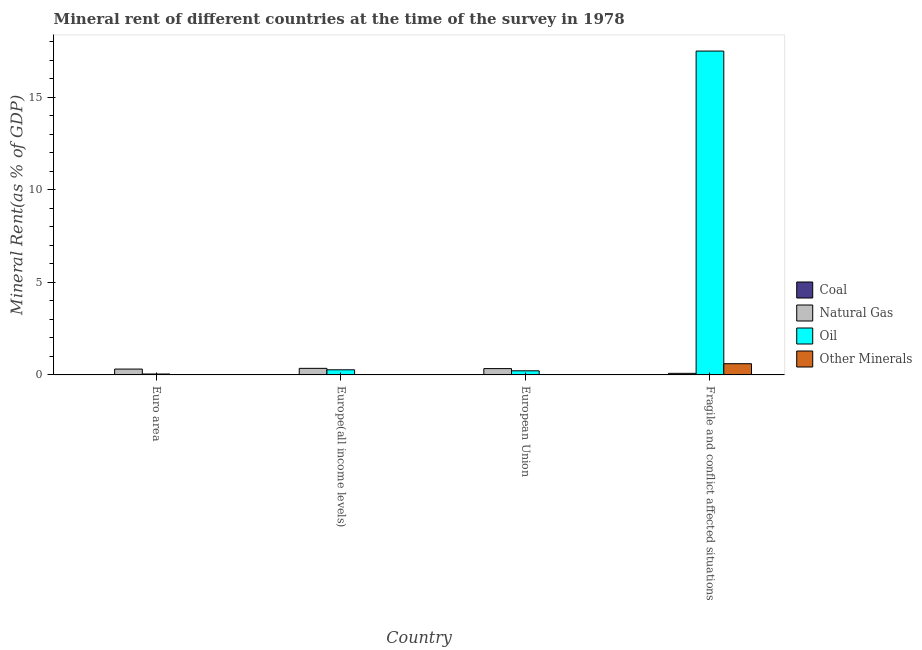Are the number of bars on each tick of the X-axis equal?
Provide a short and direct response. Yes. How many bars are there on the 3rd tick from the left?
Offer a very short reply. 4. What is the natural gas rent in Europe(all income levels)?
Give a very brief answer. 0.35. Across all countries, what is the maximum natural gas rent?
Provide a short and direct response. 0.35. Across all countries, what is the minimum oil rent?
Your response must be concise. 0.05. In which country was the coal rent maximum?
Provide a succinct answer. Fragile and conflict affected situations. What is the total  rent of other minerals in the graph?
Provide a short and direct response. 0.64. What is the difference between the oil rent in Europe(all income levels) and that in Fragile and conflict affected situations?
Offer a terse response. -17.23. What is the difference between the  rent of other minerals in Euro area and the natural gas rent in European Union?
Provide a succinct answer. -0.33. What is the average  rent of other minerals per country?
Give a very brief answer. 0.16. What is the difference between the oil rent and natural gas rent in European Union?
Ensure brevity in your answer.  -0.12. In how many countries, is the coal rent greater than 4 %?
Provide a short and direct response. 0. What is the ratio of the coal rent in Europe(all income levels) to that in Fragile and conflict affected situations?
Keep it short and to the point. 0.2. What is the difference between the highest and the second highest natural gas rent?
Provide a succinct answer. 0.01. What is the difference between the highest and the lowest natural gas rent?
Make the answer very short. 0.27. In how many countries, is the coal rent greater than the average coal rent taken over all countries?
Make the answer very short. 1. Is the sum of the natural gas rent in European Union and Fragile and conflict affected situations greater than the maximum oil rent across all countries?
Make the answer very short. No. Is it the case that in every country, the sum of the coal rent and oil rent is greater than the sum of  rent of other minerals and natural gas rent?
Make the answer very short. No. What does the 4th bar from the left in European Union represents?
Keep it short and to the point. Other Minerals. What does the 2nd bar from the right in European Union represents?
Your answer should be compact. Oil. Is it the case that in every country, the sum of the coal rent and natural gas rent is greater than the oil rent?
Provide a short and direct response. No. How many bars are there?
Your answer should be compact. 16. Are all the bars in the graph horizontal?
Your answer should be compact. No. How many countries are there in the graph?
Your answer should be very brief. 4. Are the values on the major ticks of Y-axis written in scientific E-notation?
Offer a very short reply. No. Does the graph contain grids?
Provide a succinct answer. No. What is the title of the graph?
Keep it short and to the point. Mineral rent of different countries at the time of the survey in 1978. What is the label or title of the X-axis?
Ensure brevity in your answer.  Country. What is the label or title of the Y-axis?
Ensure brevity in your answer.  Mineral Rent(as % of GDP). What is the Mineral Rent(as % of GDP) of Coal in Euro area?
Your answer should be compact. 0. What is the Mineral Rent(as % of GDP) in Natural Gas in Euro area?
Make the answer very short. 0.32. What is the Mineral Rent(as % of GDP) in Oil in Euro area?
Offer a very short reply. 0.05. What is the Mineral Rent(as % of GDP) of Other Minerals in Euro area?
Offer a very short reply. 0.01. What is the Mineral Rent(as % of GDP) of Coal in Europe(all income levels)?
Provide a succinct answer. 0. What is the Mineral Rent(as % of GDP) in Natural Gas in Europe(all income levels)?
Provide a succinct answer. 0.35. What is the Mineral Rent(as % of GDP) in Oil in Europe(all income levels)?
Your answer should be very brief. 0.28. What is the Mineral Rent(as % of GDP) of Other Minerals in Europe(all income levels)?
Offer a terse response. 0.01. What is the Mineral Rent(as % of GDP) in Coal in European Union?
Offer a very short reply. 0. What is the Mineral Rent(as % of GDP) of Natural Gas in European Union?
Offer a terse response. 0.34. What is the Mineral Rent(as % of GDP) in Oil in European Union?
Provide a short and direct response. 0.22. What is the Mineral Rent(as % of GDP) in Other Minerals in European Union?
Your answer should be compact. 0.01. What is the Mineral Rent(as % of GDP) in Coal in Fragile and conflict affected situations?
Offer a very short reply. 0.02. What is the Mineral Rent(as % of GDP) of Natural Gas in Fragile and conflict affected situations?
Your answer should be compact. 0.08. What is the Mineral Rent(as % of GDP) in Oil in Fragile and conflict affected situations?
Provide a succinct answer. 17.5. What is the Mineral Rent(as % of GDP) in Other Minerals in Fragile and conflict affected situations?
Offer a terse response. 0.61. Across all countries, what is the maximum Mineral Rent(as % of GDP) of Coal?
Provide a short and direct response. 0.02. Across all countries, what is the maximum Mineral Rent(as % of GDP) of Natural Gas?
Give a very brief answer. 0.35. Across all countries, what is the maximum Mineral Rent(as % of GDP) in Oil?
Provide a succinct answer. 17.5. Across all countries, what is the maximum Mineral Rent(as % of GDP) of Other Minerals?
Ensure brevity in your answer.  0.61. Across all countries, what is the minimum Mineral Rent(as % of GDP) of Coal?
Your answer should be compact. 0. Across all countries, what is the minimum Mineral Rent(as % of GDP) of Natural Gas?
Your answer should be very brief. 0.08. Across all countries, what is the minimum Mineral Rent(as % of GDP) in Oil?
Offer a very short reply. 0.05. Across all countries, what is the minimum Mineral Rent(as % of GDP) of Other Minerals?
Ensure brevity in your answer.  0.01. What is the total Mineral Rent(as % of GDP) of Coal in the graph?
Give a very brief answer. 0.03. What is the total Mineral Rent(as % of GDP) in Natural Gas in the graph?
Ensure brevity in your answer.  1.1. What is the total Mineral Rent(as % of GDP) of Oil in the graph?
Your response must be concise. 18.05. What is the total Mineral Rent(as % of GDP) of Other Minerals in the graph?
Your response must be concise. 0.64. What is the difference between the Mineral Rent(as % of GDP) of Coal in Euro area and that in Europe(all income levels)?
Your answer should be compact. -0. What is the difference between the Mineral Rent(as % of GDP) of Natural Gas in Euro area and that in Europe(all income levels)?
Offer a very short reply. -0.04. What is the difference between the Mineral Rent(as % of GDP) of Oil in Euro area and that in Europe(all income levels)?
Provide a succinct answer. -0.23. What is the difference between the Mineral Rent(as % of GDP) in Other Minerals in Euro area and that in Europe(all income levels)?
Your answer should be compact. -0. What is the difference between the Mineral Rent(as % of GDP) in Coal in Euro area and that in European Union?
Make the answer very short. -0. What is the difference between the Mineral Rent(as % of GDP) of Natural Gas in Euro area and that in European Union?
Provide a succinct answer. -0.03. What is the difference between the Mineral Rent(as % of GDP) in Oil in Euro area and that in European Union?
Give a very brief answer. -0.17. What is the difference between the Mineral Rent(as % of GDP) of Other Minerals in Euro area and that in European Union?
Your response must be concise. -0. What is the difference between the Mineral Rent(as % of GDP) of Coal in Euro area and that in Fragile and conflict affected situations?
Ensure brevity in your answer.  -0.02. What is the difference between the Mineral Rent(as % of GDP) in Natural Gas in Euro area and that in Fragile and conflict affected situations?
Your answer should be compact. 0.23. What is the difference between the Mineral Rent(as % of GDP) of Oil in Euro area and that in Fragile and conflict affected situations?
Your answer should be compact. -17.46. What is the difference between the Mineral Rent(as % of GDP) in Other Minerals in Euro area and that in Fragile and conflict affected situations?
Provide a short and direct response. -0.6. What is the difference between the Mineral Rent(as % of GDP) of Coal in Europe(all income levels) and that in European Union?
Offer a very short reply. -0. What is the difference between the Mineral Rent(as % of GDP) of Natural Gas in Europe(all income levels) and that in European Union?
Provide a succinct answer. 0.01. What is the difference between the Mineral Rent(as % of GDP) in Oil in Europe(all income levels) and that in European Union?
Offer a very short reply. 0.05. What is the difference between the Mineral Rent(as % of GDP) of Other Minerals in Europe(all income levels) and that in European Union?
Provide a succinct answer. 0. What is the difference between the Mineral Rent(as % of GDP) in Coal in Europe(all income levels) and that in Fragile and conflict affected situations?
Make the answer very short. -0.02. What is the difference between the Mineral Rent(as % of GDP) in Natural Gas in Europe(all income levels) and that in Fragile and conflict affected situations?
Ensure brevity in your answer.  0.27. What is the difference between the Mineral Rent(as % of GDP) in Oil in Europe(all income levels) and that in Fragile and conflict affected situations?
Give a very brief answer. -17.23. What is the difference between the Mineral Rent(as % of GDP) in Other Minerals in Europe(all income levels) and that in Fragile and conflict affected situations?
Make the answer very short. -0.59. What is the difference between the Mineral Rent(as % of GDP) in Coal in European Union and that in Fragile and conflict affected situations?
Your answer should be very brief. -0.02. What is the difference between the Mineral Rent(as % of GDP) in Natural Gas in European Union and that in Fragile and conflict affected situations?
Offer a very short reply. 0.26. What is the difference between the Mineral Rent(as % of GDP) of Oil in European Union and that in Fragile and conflict affected situations?
Ensure brevity in your answer.  -17.28. What is the difference between the Mineral Rent(as % of GDP) of Other Minerals in European Union and that in Fragile and conflict affected situations?
Make the answer very short. -0.6. What is the difference between the Mineral Rent(as % of GDP) of Coal in Euro area and the Mineral Rent(as % of GDP) of Natural Gas in Europe(all income levels)?
Offer a terse response. -0.35. What is the difference between the Mineral Rent(as % of GDP) in Coal in Euro area and the Mineral Rent(as % of GDP) in Oil in Europe(all income levels)?
Your response must be concise. -0.27. What is the difference between the Mineral Rent(as % of GDP) in Coal in Euro area and the Mineral Rent(as % of GDP) in Other Minerals in Europe(all income levels)?
Offer a terse response. -0.01. What is the difference between the Mineral Rent(as % of GDP) in Natural Gas in Euro area and the Mineral Rent(as % of GDP) in Oil in Europe(all income levels)?
Keep it short and to the point. 0.04. What is the difference between the Mineral Rent(as % of GDP) in Natural Gas in Euro area and the Mineral Rent(as % of GDP) in Other Minerals in Europe(all income levels)?
Make the answer very short. 0.3. What is the difference between the Mineral Rent(as % of GDP) in Oil in Euro area and the Mineral Rent(as % of GDP) in Other Minerals in Europe(all income levels)?
Provide a succinct answer. 0.04. What is the difference between the Mineral Rent(as % of GDP) in Coal in Euro area and the Mineral Rent(as % of GDP) in Natural Gas in European Union?
Provide a short and direct response. -0.34. What is the difference between the Mineral Rent(as % of GDP) of Coal in Euro area and the Mineral Rent(as % of GDP) of Oil in European Union?
Give a very brief answer. -0.22. What is the difference between the Mineral Rent(as % of GDP) of Coal in Euro area and the Mineral Rent(as % of GDP) of Other Minerals in European Union?
Your answer should be compact. -0.01. What is the difference between the Mineral Rent(as % of GDP) in Natural Gas in Euro area and the Mineral Rent(as % of GDP) in Oil in European Union?
Your answer should be compact. 0.09. What is the difference between the Mineral Rent(as % of GDP) of Natural Gas in Euro area and the Mineral Rent(as % of GDP) of Other Minerals in European Union?
Keep it short and to the point. 0.31. What is the difference between the Mineral Rent(as % of GDP) of Oil in Euro area and the Mineral Rent(as % of GDP) of Other Minerals in European Union?
Your answer should be compact. 0.04. What is the difference between the Mineral Rent(as % of GDP) of Coal in Euro area and the Mineral Rent(as % of GDP) of Natural Gas in Fragile and conflict affected situations?
Provide a short and direct response. -0.08. What is the difference between the Mineral Rent(as % of GDP) in Coal in Euro area and the Mineral Rent(as % of GDP) in Oil in Fragile and conflict affected situations?
Provide a succinct answer. -17.5. What is the difference between the Mineral Rent(as % of GDP) in Coal in Euro area and the Mineral Rent(as % of GDP) in Other Minerals in Fragile and conflict affected situations?
Your response must be concise. -0.6. What is the difference between the Mineral Rent(as % of GDP) in Natural Gas in Euro area and the Mineral Rent(as % of GDP) in Oil in Fragile and conflict affected situations?
Provide a succinct answer. -17.19. What is the difference between the Mineral Rent(as % of GDP) of Natural Gas in Euro area and the Mineral Rent(as % of GDP) of Other Minerals in Fragile and conflict affected situations?
Provide a short and direct response. -0.29. What is the difference between the Mineral Rent(as % of GDP) of Oil in Euro area and the Mineral Rent(as % of GDP) of Other Minerals in Fragile and conflict affected situations?
Make the answer very short. -0.56. What is the difference between the Mineral Rent(as % of GDP) in Coal in Europe(all income levels) and the Mineral Rent(as % of GDP) in Natural Gas in European Union?
Keep it short and to the point. -0.34. What is the difference between the Mineral Rent(as % of GDP) of Coal in Europe(all income levels) and the Mineral Rent(as % of GDP) of Oil in European Union?
Provide a short and direct response. -0.22. What is the difference between the Mineral Rent(as % of GDP) in Coal in Europe(all income levels) and the Mineral Rent(as % of GDP) in Other Minerals in European Union?
Make the answer very short. -0.01. What is the difference between the Mineral Rent(as % of GDP) in Natural Gas in Europe(all income levels) and the Mineral Rent(as % of GDP) in Oil in European Union?
Make the answer very short. 0.13. What is the difference between the Mineral Rent(as % of GDP) of Natural Gas in Europe(all income levels) and the Mineral Rent(as % of GDP) of Other Minerals in European Union?
Your response must be concise. 0.35. What is the difference between the Mineral Rent(as % of GDP) in Oil in Europe(all income levels) and the Mineral Rent(as % of GDP) in Other Minerals in European Union?
Give a very brief answer. 0.27. What is the difference between the Mineral Rent(as % of GDP) in Coal in Europe(all income levels) and the Mineral Rent(as % of GDP) in Natural Gas in Fragile and conflict affected situations?
Keep it short and to the point. -0.08. What is the difference between the Mineral Rent(as % of GDP) in Coal in Europe(all income levels) and the Mineral Rent(as % of GDP) in Oil in Fragile and conflict affected situations?
Your answer should be very brief. -17.5. What is the difference between the Mineral Rent(as % of GDP) of Coal in Europe(all income levels) and the Mineral Rent(as % of GDP) of Other Minerals in Fragile and conflict affected situations?
Ensure brevity in your answer.  -0.6. What is the difference between the Mineral Rent(as % of GDP) of Natural Gas in Europe(all income levels) and the Mineral Rent(as % of GDP) of Oil in Fragile and conflict affected situations?
Provide a succinct answer. -17.15. What is the difference between the Mineral Rent(as % of GDP) of Natural Gas in Europe(all income levels) and the Mineral Rent(as % of GDP) of Other Minerals in Fragile and conflict affected situations?
Provide a short and direct response. -0.25. What is the difference between the Mineral Rent(as % of GDP) of Oil in Europe(all income levels) and the Mineral Rent(as % of GDP) of Other Minerals in Fragile and conflict affected situations?
Make the answer very short. -0.33. What is the difference between the Mineral Rent(as % of GDP) of Coal in European Union and the Mineral Rent(as % of GDP) of Natural Gas in Fragile and conflict affected situations?
Make the answer very short. -0.08. What is the difference between the Mineral Rent(as % of GDP) in Coal in European Union and the Mineral Rent(as % of GDP) in Oil in Fragile and conflict affected situations?
Offer a terse response. -17.5. What is the difference between the Mineral Rent(as % of GDP) in Coal in European Union and the Mineral Rent(as % of GDP) in Other Minerals in Fragile and conflict affected situations?
Make the answer very short. -0.6. What is the difference between the Mineral Rent(as % of GDP) of Natural Gas in European Union and the Mineral Rent(as % of GDP) of Oil in Fragile and conflict affected situations?
Offer a terse response. -17.16. What is the difference between the Mineral Rent(as % of GDP) in Natural Gas in European Union and the Mineral Rent(as % of GDP) in Other Minerals in Fragile and conflict affected situations?
Provide a succinct answer. -0.26. What is the difference between the Mineral Rent(as % of GDP) in Oil in European Union and the Mineral Rent(as % of GDP) in Other Minerals in Fragile and conflict affected situations?
Give a very brief answer. -0.38. What is the average Mineral Rent(as % of GDP) of Coal per country?
Offer a terse response. 0.01. What is the average Mineral Rent(as % of GDP) in Natural Gas per country?
Provide a short and direct response. 0.27. What is the average Mineral Rent(as % of GDP) in Oil per country?
Keep it short and to the point. 4.51. What is the average Mineral Rent(as % of GDP) of Other Minerals per country?
Keep it short and to the point. 0.16. What is the difference between the Mineral Rent(as % of GDP) of Coal and Mineral Rent(as % of GDP) of Natural Gas in Euro area?
Keep it short and to the point. -0.31. What is the difference between the Mineral Rent(as % of GDP) of Coal and Mineral Rent(as % of GDP) of Oil in Euro area?
Give a very brief answer. -0.05. What is the difference between the Mineral Rent(as % of GDP) in Coal and Mineral Rent(as % of GDP) in Other Minerals in Euro area?
Provide a short and direct response. -0.01. What is the difference between the Mineral Rent(as % of GDP) of Natural Gas and Mineral Rent(as % of GDP) of Oil in Euro area?
Offer a very short reply. 0.27. What is the difference between the Mineral Rent(as % of GDP) in Natural Gas and Mineral Rent(as % of GDP) in Other Minerals in Euro area?
Your answer should be very brief. 0.31. What is the difference between the Mineral Rent(as % of GDP) of Oil and Mineral Rent(as % of GDP) of Other Minerals in Euro area?
Keep it short and to the point. 0.04. What is the difference between the Mineral Rent(as % of GDP) of Coal and Mineral Rent(as % of GDP) of Natural Gas in Europe(all income levels)?
Your answer should be very brief. -0.35. What is the difference between the Mineral Rent(as % of GDP) of Coal and Mineral Rent(as % of GDP) of Oil in Europe(all income levels)?
Your answer should be very brief. -0.27. What is the difference between the Mineral Rent(as % of GDP) in Coal and Mineral Rent(as % of GDP) in Other Minerals in Europe(all income levels)?
Your answer should be very brief. -0.01. What is the difference between the Mineral Rent(as % of GDP) in Natural Gas and Mineral Rent(as % of GDP) in Oil in Europe(all income levels)?
Make the answer very short. 0.08. What is the difference between the Mineral Rent(as % of GDP) of Natural Gas and Mineral Rent(as % of GDP) of Other Minerals in Europe(all income levels)?
Offer a terse response. 0.34. What is the difference between the Mineral Rent(as % of GDP) of Oil and Mineral Rent(as % of GDP) of Other Minerals in Europe(all income levels)?
Your response must be concise. 0.26. What is the difference between the Mineral Rent(as % of GDP) in Coal and Mineral Rent(as % of GDP) in Natural Gas in European Union?
Offer a very short reply. -0.34. What is the difference between the Mineral Rent(as % of GDP) in Coal and Mineral Rent(as % of GDP) in Oil in European Union?
Provide a succinct answer. -0.22. What is the difference between the Mineral Rent(as % of GDP) in Coal and Mineral Rent(as % of GDP) in Other Minerals in European Union?
Provide a short and direct response. -0.01. What is the difference between the Mineral Rent(as % of GDP) in Natural Gas and Mineral Rent(as % of GDP) in Oil in European Union?
Offer a terse response. 0.12. What is the difference between the Mineral Rent(as % of GDP) of Natural Gas and Mineral Rent(as % of GDP) of Other Minerals in European Union?
Ensure brevity in your answer.  0.33. What is the difference between the Mineral Rent(as % of GDP) in Oil and Mineral Rent(as % of GDP) in Other Minerals in European Union?
Provide a succinct answer. 0.21. What is the difference between the Mineral Rent(as % of GDP) in Coal and Mineral Rent(as % of GDP) in Natural Gas in Fragile and conflict affected situations?
Provide a succinct answer. -0.06. What is the difference between the Mineral Rent(as % of GDP) of Coal and Mineral Rent(as % of GDP) of Oil in Fragile and conflict affected situations?
Make the answer very short. -17.48. What is the difference between the Mineral Rent(as % of GDP) of Coal and Mineral Rent(as % of GDP) of Other Minerals in Fragile and conflict affected situations?
Make the answer very short. -0.58. What is the difference between the Mineral Rent(as % of GDP) in Natural Gas and Mineral Rent(as % of GDP) in Oil in Fragile and conflict affected situations?
Your response must be concise. -17.42. What is the difference between the Mineral Rent(as % of GDP) in Natural Gas and Mineral Rent(as % of GDP) in Other Minerals in Fragile and conflict affected situations?
Your answer should be compact. -0.52. What is the difference between the Mineral Rent(as % of GDP) in Oil and Mineral Rent(as % of GDP) in Other Minerals in Fragile and conflict affected situations?
Offer a terse response. 16.9. What is the ratio of the Mineral Rent(as % of GDP) of Coal in Euro area to that in Europe(all income levels)?
Your response must be concise. 0.69. What is the ratio of the Mineral Rent(as % of GDP) of Natural Gas in Euro area to that in Europe(all income levels)?
Your answer should be compact. 0.89. What is the ratio of the Mineral Rent(as % of GDP) in Oil in Euro area to that in Europe(all income levels)?
Offer a terse response. 0.18. What is the ratio of the Mineral Rent(as % of GDP) of Other Minerals in Euro area to that in Europe(all income levels)?
Your answer should be very brief. 0.81. What is the ratio of the Mineral Rent(as % of GDP) in Coal in Euro area to that in European Union?
Give a very brief answer. 0.68. What is the ratio of the Mineral Rent(as % of GDP) of Natural Gas in Euro area to that in European Union?
Your response must be concise. 0.93. What is the ratio of the Mineral Rent(as % of GDP) in Oil in Euro area to that in European Union?
Make the answer very short. 0.22. What is the ratio of the Mineral Rent(as % of GDP) of Other Minerals in Euro area to that in European Union?
Make the answer very short. 0.95. What is the ratio of the Mineral Rent(as % of GDP) in Coal in Euro area to that in Fragile and conflict affected situations?
Your response must be concise. 0.14. What is the ratio of the Mineral Rent(as % of GDP) in Natural Gas in Euro area to that in Fragile and conflict affected situations?
Offer a very short reply. 3.76. What is the ratio of the Mineral Rent(as % of GDP) of Oil in Euro area to that in Fragile and conflict affected situations?
Make the answer very short. 0. What is the ratio of the Mineral Rent(as % of GDP) in Other Minerals in Euro area to that in Fragile and conflict affected situations?
Provide a succinct answer. 0.01. What is the ratio of the Mineral Rent(as % of GDP) in Coal in Europe(all income levels) to that in European Union?
Ensure brevity in your answer.  0.98. What is the ratio of the Mineral Rent(as % of GDP) of Natural Gas in Europe(all income levels) to that in European Union?
Provide a short and direct response. 1.04. What is the ratio of the Mineral Rent(as % of GDP) of Oil in Europe(all income levels) to that in European Union?
Provide a succinct answer. 1.25. What is the ratio of the Mineral Rent(as % of GDP) of Other Minerals in Europe(all income levels) to that in European Union?
Your response must be concise. 1.17. What is the ratio of the Mineral Rent(as % of GDP) of Coal in Europe(all income levels) to that in Fragile and conflict affected situations?
Provide a succinct answer. 0.2. What is the ratio of the Mineral Rent(as % of GDP) of Natural Gas in Europe(all income levels) to that in Fragile and conflict affected situations?
Keep it short and to the point. 4.22. What is the ratio of the Mineral Rent(as % of GDP) of Oil in Europe(all income levels) to that in Fragile and conflict affected situations?
Offer a terse response. 0.02. What is the ratio of the Mineral Rent(as % of GDP) of Other Minerals in Europe(all income levels) to that in Fragile and conflict affected situations?
Ensure brevity in your answer.  0.02. What is the ratio of the Mineral Rent(as % of GDP) in Coal in European Union to that in Fragile and conflict affected situations?
Your answer should be compact. 0.2. What is the ratio of the Mineral Rent(as % of GDP) of Natural Gas in European Union to that in Fragile and conflict affected situations?
Your answer should be very brief. 4.06. What is the ratio of the Mineral Rent(as % of GDP) of Oil in European Union to that in Fragile and conflict affected situations?
Give a very brief answer. 0.01. What is the ratio of the Mineral Rent(as % of GDP) of Other Minerals in European Union to that in Fragile and conflict affected situations?
Provide a succinct answer. 0.02. What is the difference between the highest and the second highest Mineral Rent(as % of GDP) of Coal?
Keep it short and to the point. 0.02. What is the difference between the highest and the second highest Mineral Rent(as % of GDP) in Natural Gas?
Your response must be concise. 0.01. What is the difference between the highest and the second highest Mineral Rent(as % of GDP) in Oil?
Your answer should be compact. 17.23. What is the difference between the highest and the second highest Mineral Rent(as % of GDP) of Other Minerals?
Make the answer very short. 0.59. What is the difference between the highest and the lowest Mineral Rent(as % of GDP) in Coal?
Provide a succinct answer. 0.02. What is the difference between the highest and the lowest Mineral Rent(as % of GDP) in Natural Gas?
Offer a very short reply. 0.27. What is the difference between the highest and the lowest Mineral Rent(as % of GDP) of Oil?
Offer a very short reply. 17.46. What is the difference between the highest and the lowest Mineral Rent(as % of GDP) in Other Minerals?
Give a very brief answer. 0.6. 